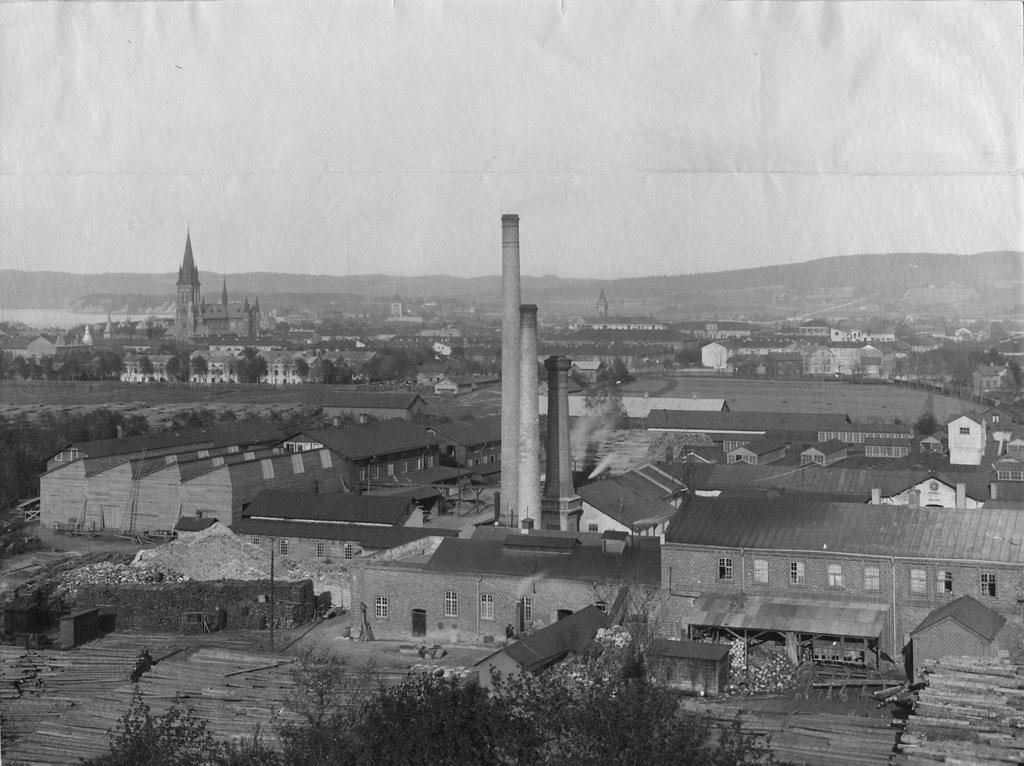What is the color scheme of the image? The image is black and white. What type of structures can be seen in the image? There are buildings with windows and towers in the image. What type of vegetation is present in the image? There are plants and trees in the image. What type of support structures are visible in the image? There are wooden poles in the image. What type of natural landscape can be seen in the image? There are hills visible in the image. What part of the environment is visible in the image? The sky is visible in the image. What type of religious symbolism can be seen in the image? There is no religious symbolism present in the image. What type of paint is used to create the image? The image is black and white, so there is no paint used to create it. 